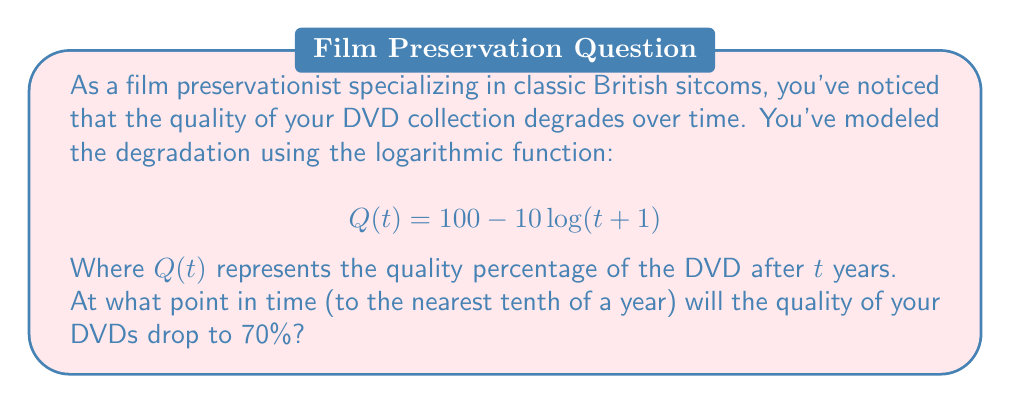Can you answer this question? To solve this problem, we need to set up an equation and solve for $t$:

1) We want to find $t$ when $Q(t) = 70$, so we can write:
   $70 = 100 - 10\log(t+1)$

2) Subtract 100 from both sides:
   $-30 = -10\log(t+1)$

3) Divide both sides by -10:
   $3 = \log(t+1)$

4) To solve for $t$, we need to apply the inverse function of logarithm, which is exponential:
   $e^3 = t+1$

5) Subtract 1 from both sides:
   $e^3 - 1 = t$

6) Calculate the value:
   $t = e^3 - 1 \approx 20.0855369$

7) Rounding to the nearest tenth:
   $t \approx 20.1$ years

Therefore, the quality of the DVDs will drop to 70% after approximately 20.1 years.
Answer: 20.1 years 